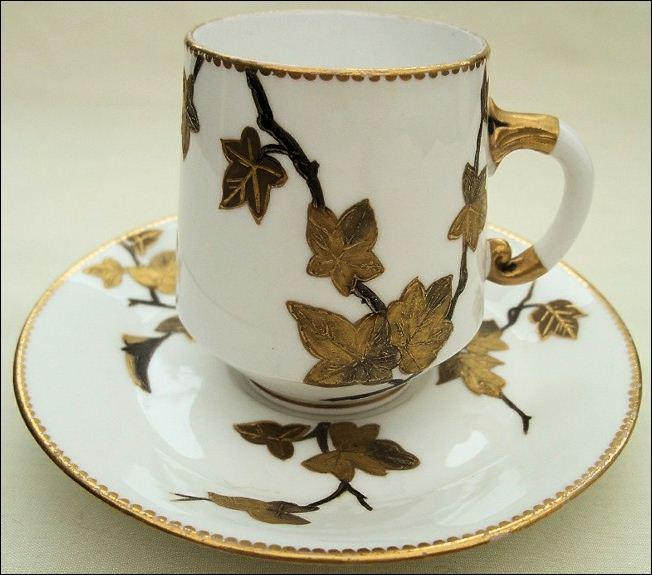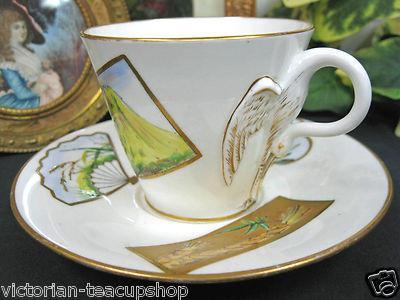The first image is the image on the left, the second image is the image on the right. Evaluate the accuracy of this statement regarding the images: "One cup is not on a saucer.". Is it true? Answer yes or no. No. 